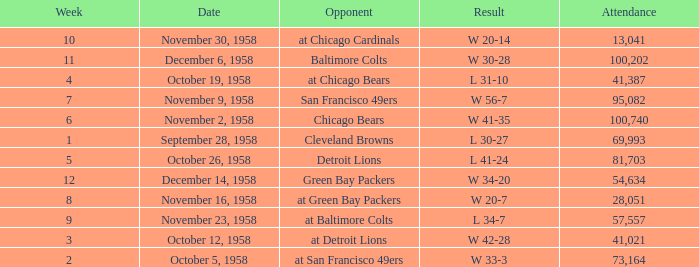What was the higest attendance on November 9, 1958? 95082.0. 